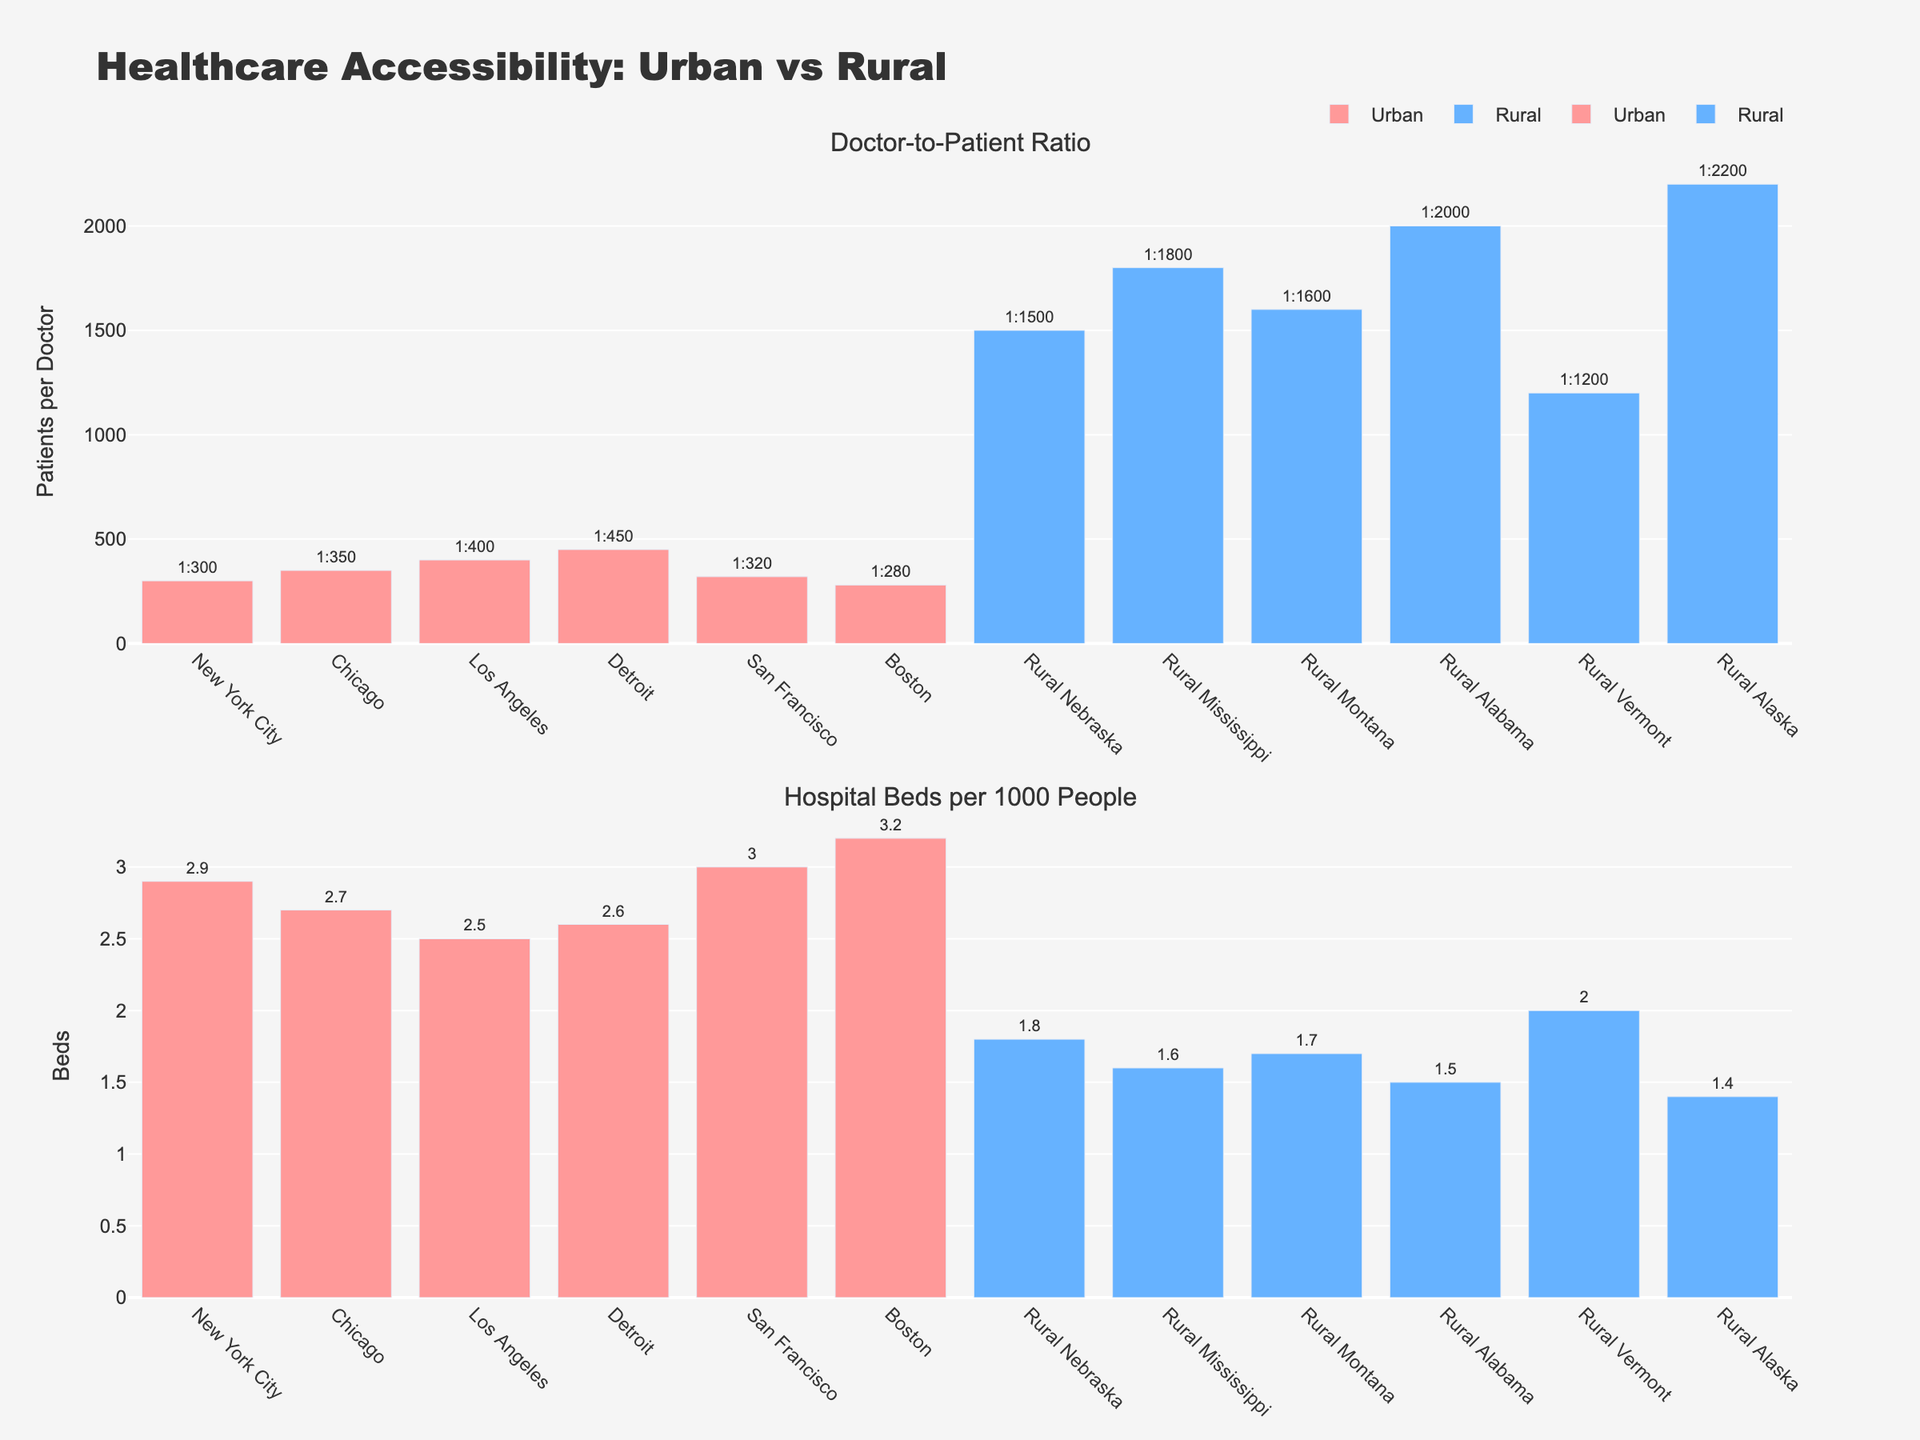what is the title of the figure? The title of the figure is located at the top of the plot. It is "Healthcare Accessibility: Urban vs Rural".
Answer: Healthcare Accessibility: Urban vs Rural how many urban areas are represented in the doctor-to-patient ratio subplot? In the doctor-to-patient ratio subplot, the urban areas' bars are colored in pink. Counting them, there are 7 bars representing urban areas.
Answer: 7 which rural area has the highest doctor-to-patient ratio? In the doctor-to-patient ratio subplot, inspect the blue bars (rural areas). The bar with the highest value represents Rural Alaska with a ratio of 1:2200.
Answer: Rural Alaska what is the average number of hospital beds per 1000 people in rural areas? Sum the hospital beds per 1000 people for all rural areas and divide by the number of rural areas. (1.8 + 1.6 + 1.7 + 1.5 + 2.0 + 1.4) / 6 = 10.0 / 6 ≈ 1.67
Answer: 1.67 which urban area has the best doctor-to-patient ratio? In the doctor-to-patient ratio subplot, find the smallest pink bar indicating the lowest doctor-to-patient ratio. Boston has the best ratio with 1:280.
Answer: Boston how do the urban and rural hospital bed availability compare based on the median value? Calculate the median by arranging the hospital beds per 1000 people values for both urban and rural areas and finding the middle value. Urban: (2.5, 2.6, 2.7, 2.9, 3.0, 3.2) → 2.8; Rural: (1.4, 1.5, 1.6, 1.7, 1.8, 2.0) → 1.65. The median value for urban areas is higher.
Answer: Urban areas have a higher median hospital bed availability (2.8 vs. 1.65) which area has the most hospital beds per 1000 people? In the hospital beds subplot, the highest bar indicates the area with the most hospital beds per 1000 people. Boston has the most with 3.2 beds per 1000 people.
Answer: Boston for Rural Vermont, how does the doctor-to-patient ratio compare to the average doctor-to-patient ratio in rural areas? Calculate the average doctor-to-patient ratio for rural areas and compare it to that of Rural Vermont. Average ratio = (1500 + 1800 + 1600 + 2000 + 1200 + 2200) / 6 = 1:1716.67, Rural Vermont’s ratio is 1:1200. Rural Vermont’s ratio is better.
Answer: Rural Vermont has a better ratio (1:1200 vs. 1:1716.67) compare the hospital bed availability between Chicago and Rural Mississippi In the hospital beds subplot, find the respective bars. Chicago has 2.7 beds per 1000 people while Rural Mississippi has 1.6 beds per 1000 people. Chicago has higher availability.
Answer: Chicago has higher availability (2.7 vs. 1.6) is there a significant difference in doctor-to-patient ratios between urban and rural areas? In the doctor-to-patient ratio subplot, the pink bars (urban) are significantly shorter (lower ratios) than the blue bars (rural), indicating a substantial difference in favor of urban areas.
Answer: Yes, urban areas have much better ratios 